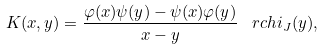Convert formula to latex. <formula><loc_0><loc_0><loc_500><loc_500>K ( x , y ) = \frac { \varphi ( x ) \psi ( y ) - \psi ( x ) \varphi ( y ) } { x - y } \, \ r c h i _ { J } ( y ) ,</formula> 